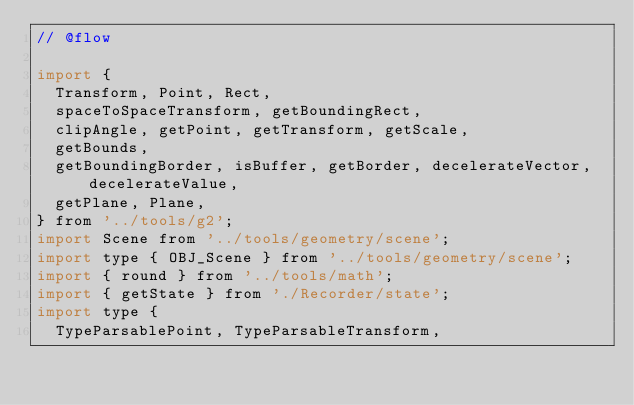Convert code to text. <code><loc_0><loc_0><loc_500><loc_500><_JavaScript_>// @flow

import {
  Transform, Point, Rect,
  spaceToSpaceTransform, getBoundingRect,
  clipAngle, getPoint, getTransform, getScale,
  getBounds,
  getBoundingBorder, isBuffer, getBorder, decelerateVector, decelerateValue,
  getPlane, Plane,
} from '../tools/g2';
import Scene from '../tools/geometry/scene';
import type { OBJ_Scene } from '../tools/geometry/scene';
import { round } from '../tools/math';
import { getState } from './Recorder/state';
import type {
  TypeParsablePoint, TypeParsableTransform,</code> 